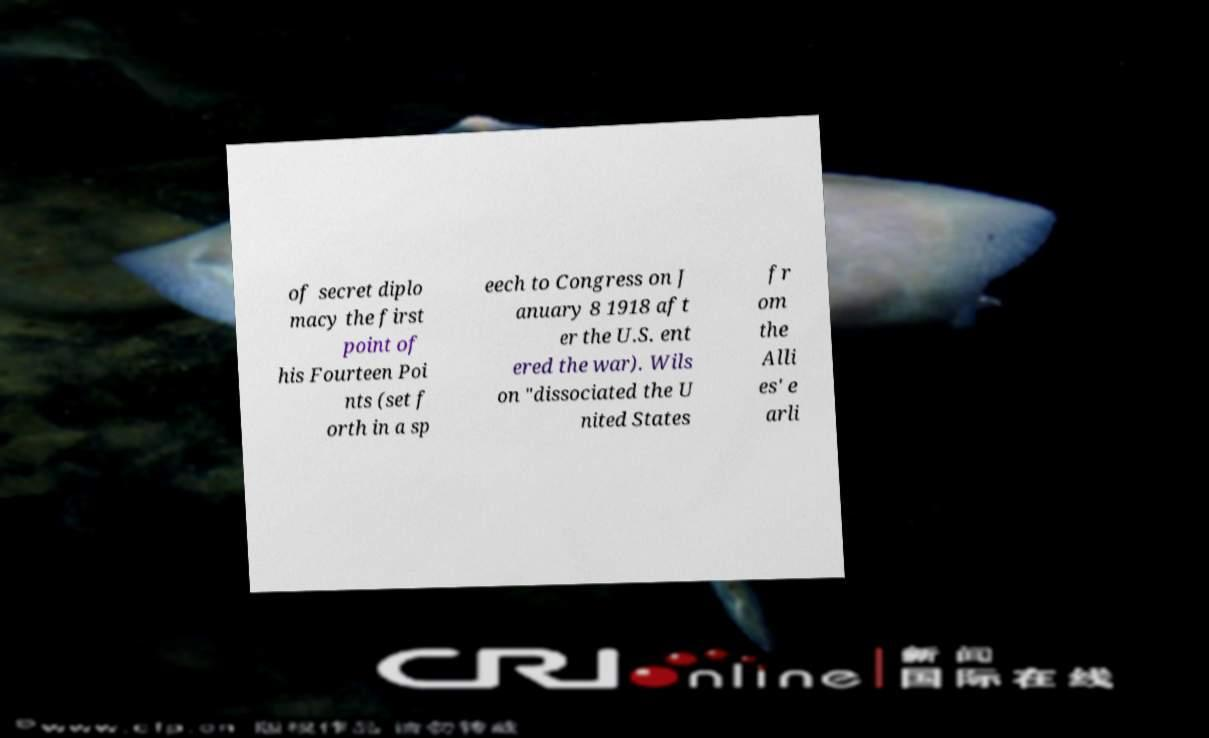I need the written content from this picture converted into text. Can you do that? of secret diplo macy the first point of his Fourteen Poi nts (set f orth in a sp eech to Congress on J anuary 8 1918 aft er the U.S. ent ered the war). Wils on "dissociated the U nited States fr om the Alli es' e arli 